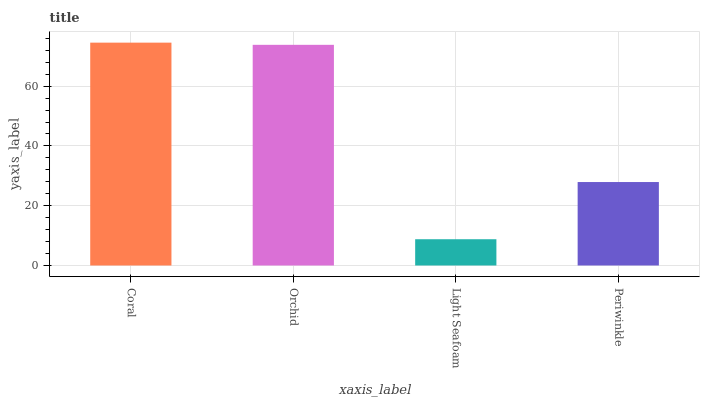Is Light Seafoam the minimum?
Answer yes or no. Yes. Is Coral the maximum?
Answer yes or no. Yes. Is Orchid the minimum?
Answer yes or no. No. Is Orchid the maximum?
Answer yes or no. No. Is Coral greater than Orchid?
Answer yes or no. Yes. Is Orchid less than Coral?
Answer yes or no. Yes. Is Orchid greater than Coral?
Answer yes or no. No. Is Coral less than Orchid?
Answer yes or no. No. Is Orchid the high median?
Answer yes or no. Yes. Is Periwinkle the low median?
Answer yes or no. Yes. Is Coral the high median?
Answer yes or no. No. Is Light Seafoam the low median?
Answer yes or no. No. 